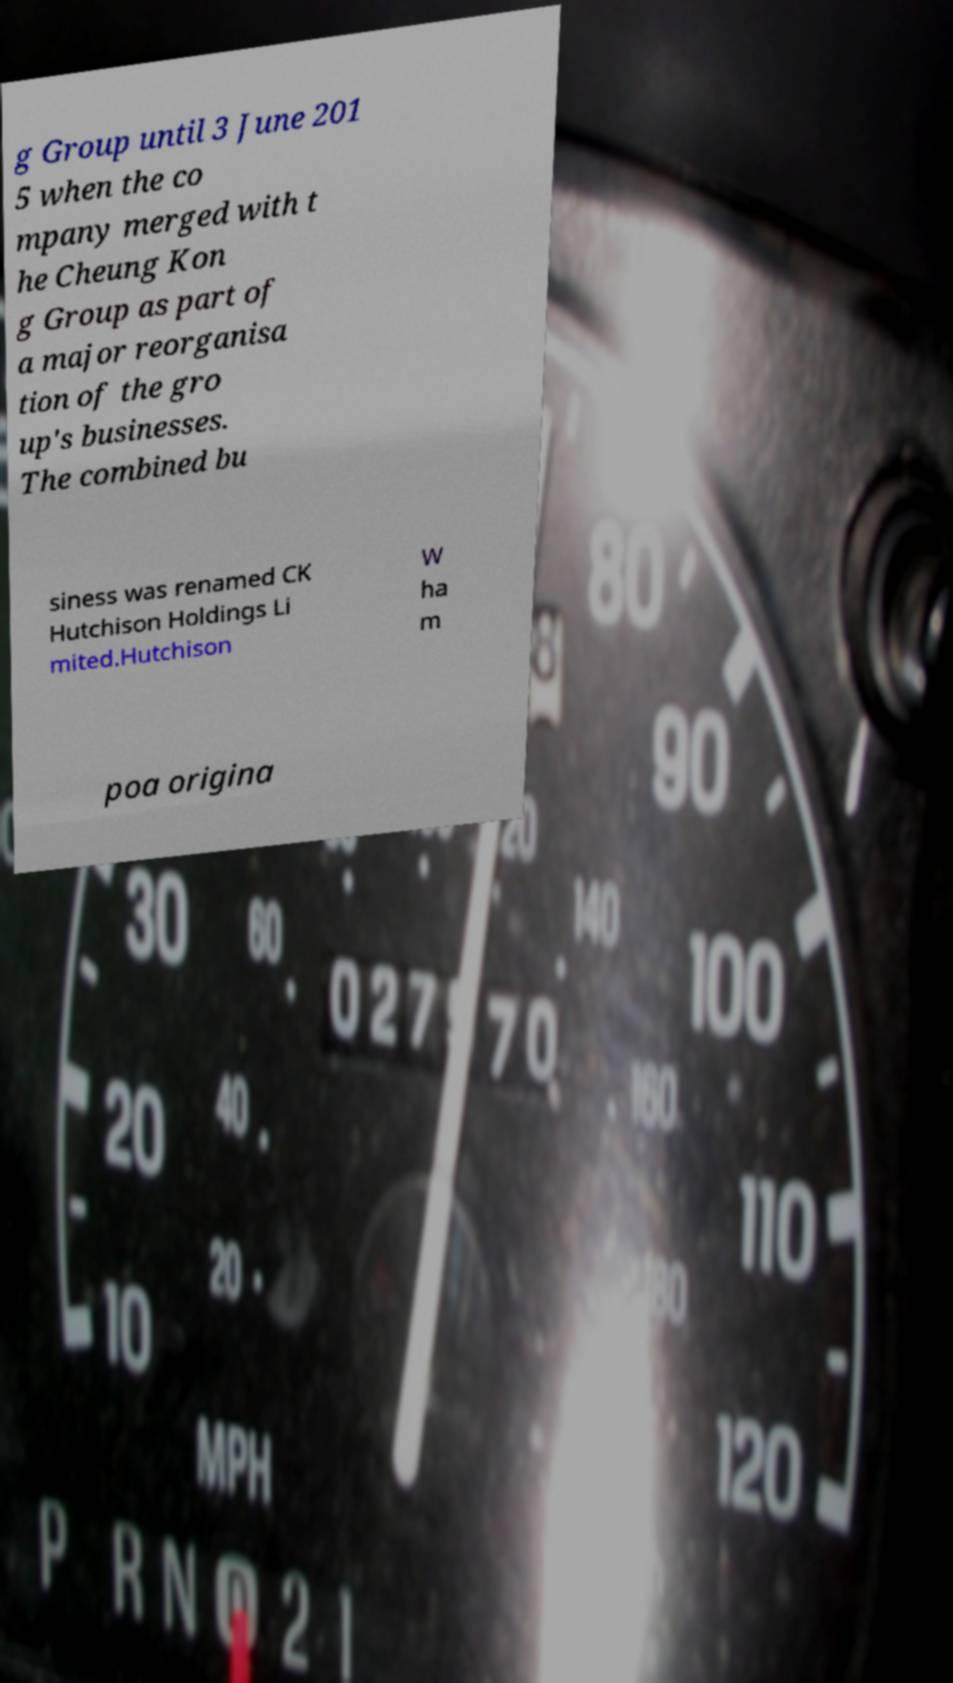I need the written content from this picture converted into text. Can you do that? g Group until 3 June 201 5 when the co mpany merged with t he Cheung Kon g Group as part of a major reorganisa tion of the gro up's businesses. The combined bu siness was renamed CK Hutchison Holdings Li mited.Hutchison W ha m poa origina 